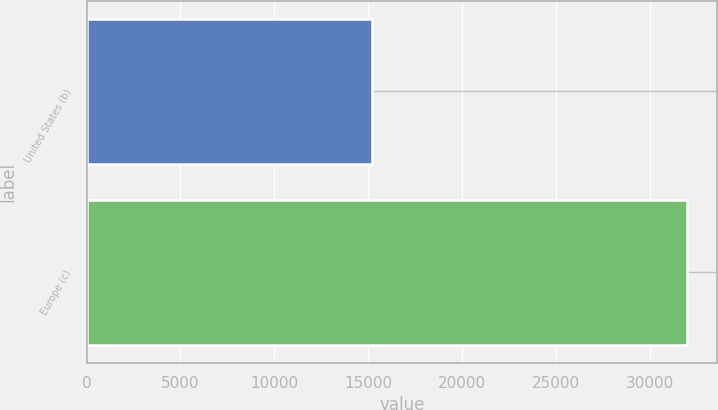Convert chart to OTSL. <chart><loc_0><loc_0><loc_500><loc_500><bar_chart><fcel>United States (b)<fcel>Europe (c)<nl><fcel>15191<fcel>31972<nl></chart> 